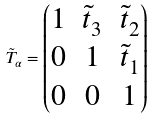<formula> <loc_0><loc_0><loc_500><loc_500>\tilde { T } _ { \alpha } = \begin{pmatrix} 1 & \tilde { t } _ { 3 } & \tilde { t } _ { 2 } \\ 0 & 1 & \tilde { t } _ { 1 } \\ 0 & 0 & 1 \end{pmatrix}</formula> 